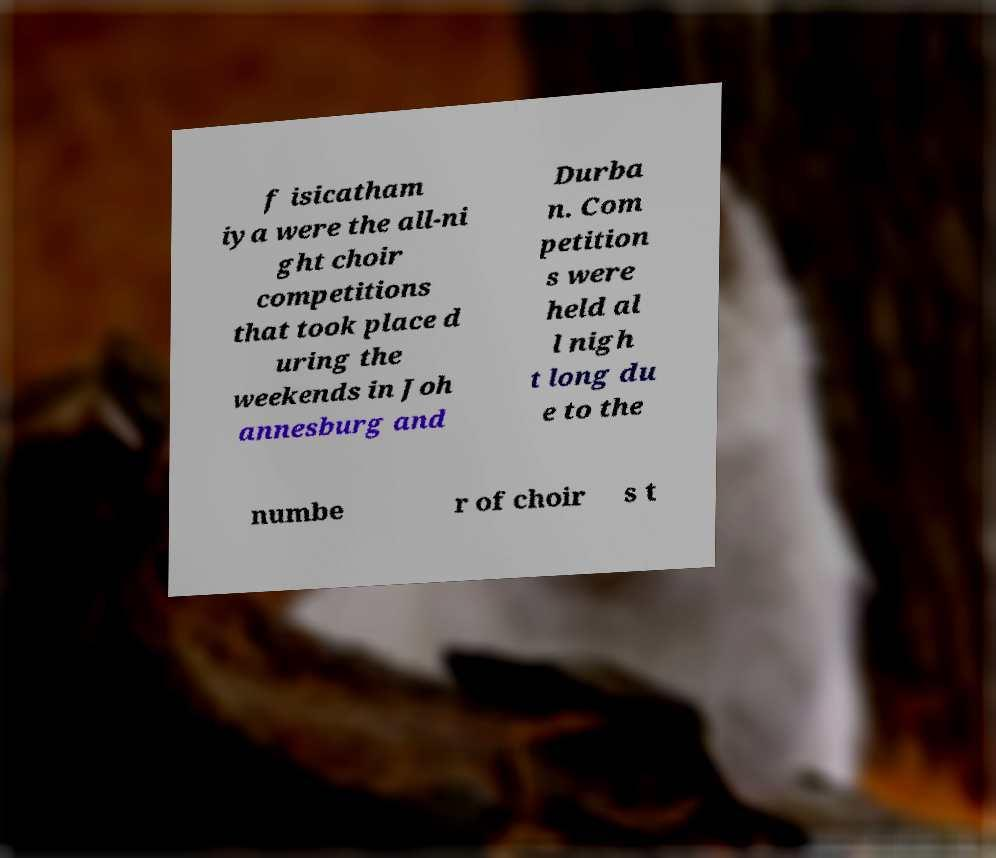Could you assist in decoding the text presented in this image and type it out clearly? f isicatham iya were the all-ni ght choir competitions that took place d uring the weekends in Joh annesburg and Durba n. Com petition s were held al l nigh t long du e to the numbe r of choir s t 